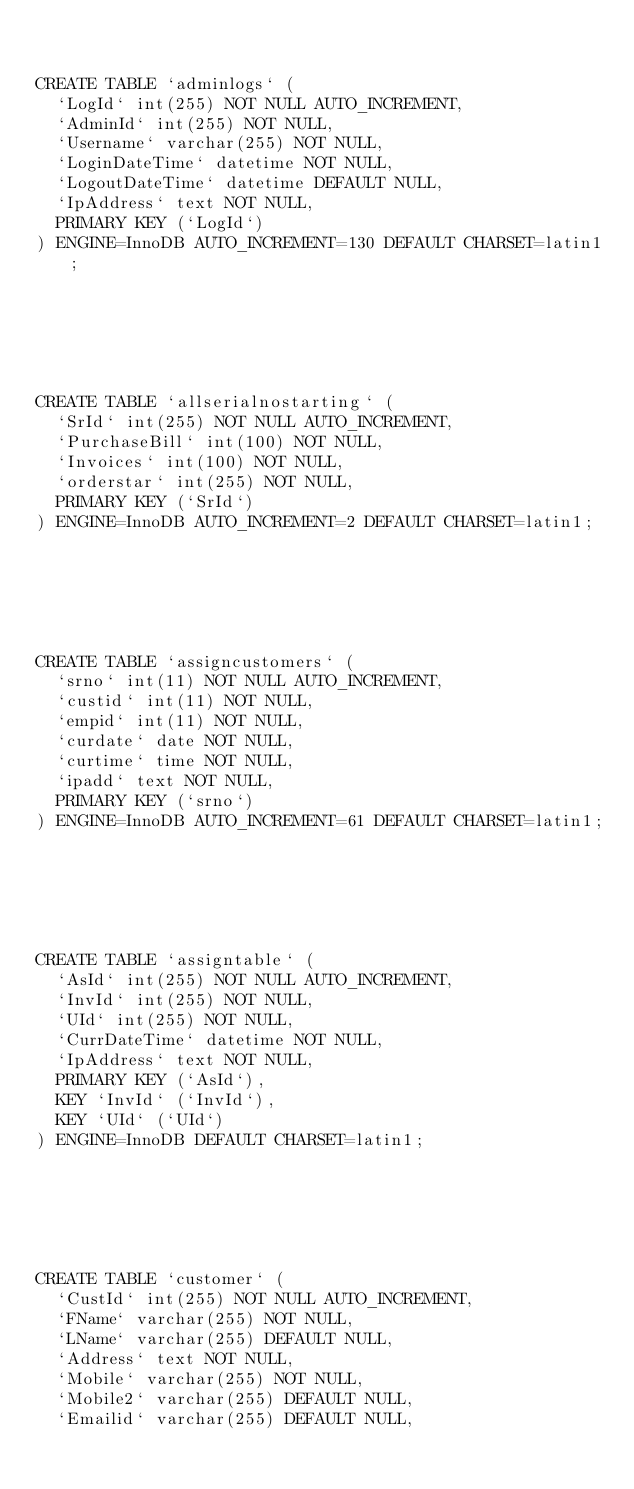<code> <loc_0><loc_0><loc_500><loc_500><_SQL_>

CREATE TABLE `adminlogs` (
  `LogId` int(255) NOT NULL AUTO_INCREMENT,
  `AdminId` int(255) NOT NULL,
  `Username` varchar(255) NOT NULL,
  `LoginDateTime` datetime NOT NULL,
  `LogoutDateTime` datetime DEFAULT NULL,
  `IpAddress` text NOT NULL,
  PRIMARY KEY (`LogId`)
) ENGINE=InnoDB AUTO_INCREMENT=130 DEFAULT CHARSET=latin1;






CREATE TABLE `allserialnostarting` (
  `SrId` int(255) NOT NULL AUTO_INCREMENT,
  `PurchaseBill` int(100) NOT NULL,
  `Invoices` int(100) NOT NULL,
  `orderstar` int(255) NOT NULL,
  PRIMARY KEY (`SrId`)
) ENGINE=InnoDB AUTO_INCREMENT=2 DEFAULT CHARSET=latin1;






CREATE TABLE `assigncustomers` (
  `srno` int(11) NOT NULL AUTO_INCREMENT,
  `custid` int(11) NOT NULL,
  `empid` int(11) NOT NULL,
  `curdate` date NOT NULL,
  `curtime` time NOT NULL,
  `ipadd` text NOT NULL,
  PRIMARY KEY (`srno`)
) ENGINE=InnoDB AUTO_INCREMENT=61 DEFAULT CHARSET=latin1;






CREATE TABLE `assigntable` (
  `AsId` int(255) NOT NULL AUTO_INCREMENT,
  `InvId` int(255) NOT NULL,
  `UId` int(255) NOT NULL,
  `CurrDateTime` datetime NOT NULL,
  `IpAddress` text NOT NULL,
  PRIMARY KEY (`AsId`),
  KEY `InvId` (`InvId`),
  KEY `UId` (`UId`)
) ENGINE=InnoDB DEFAULT CHARSET=latin1;






CREATE TABLE `customer` (
  `CustId` int(255) NOT NULL AUTO_INCREMENT,
  `FName` varchar(255) NOT NULL,
  `LName` varchar(255) DEFAULT NULL,
  `Address` text NOT NULL,
  `Mobile` varchar(255) NOT NULL,
  `Mobile2` varchar(255) DEFAULT NULL,
  `Emailid` varchar(255) DEFAULT NULL,</code> 